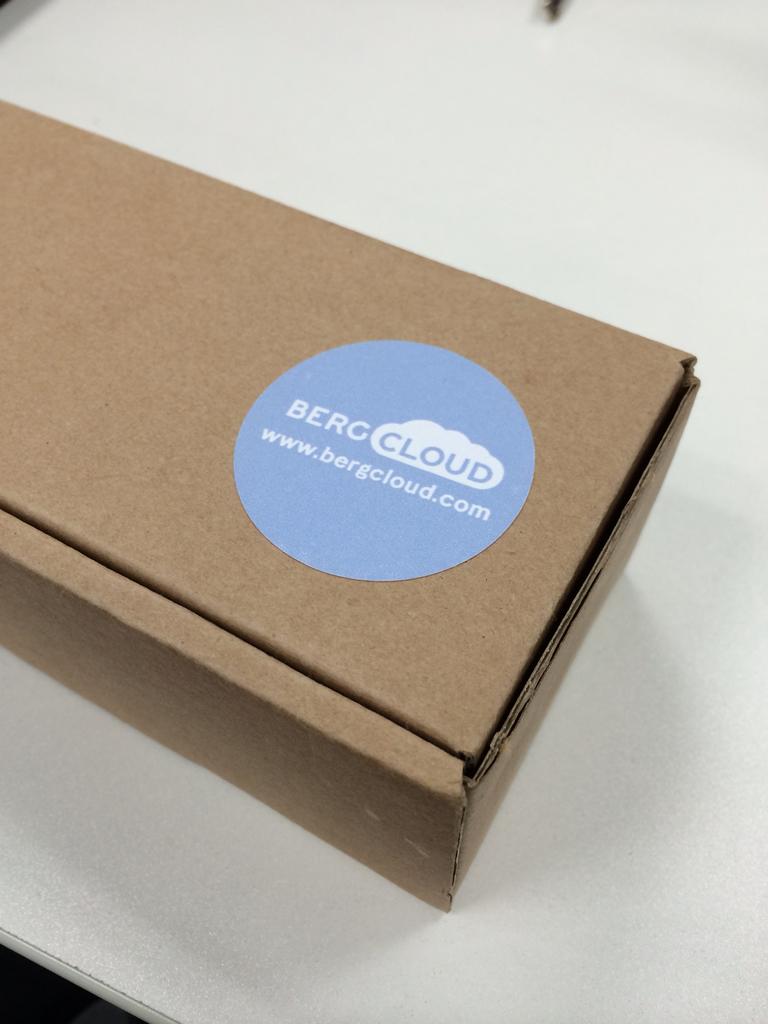What website is shown?
Offer a terse response. Www.bergcloud.com. What is the name printed on the cardboard box?
Provide a short and direct response. Berg cloud. 